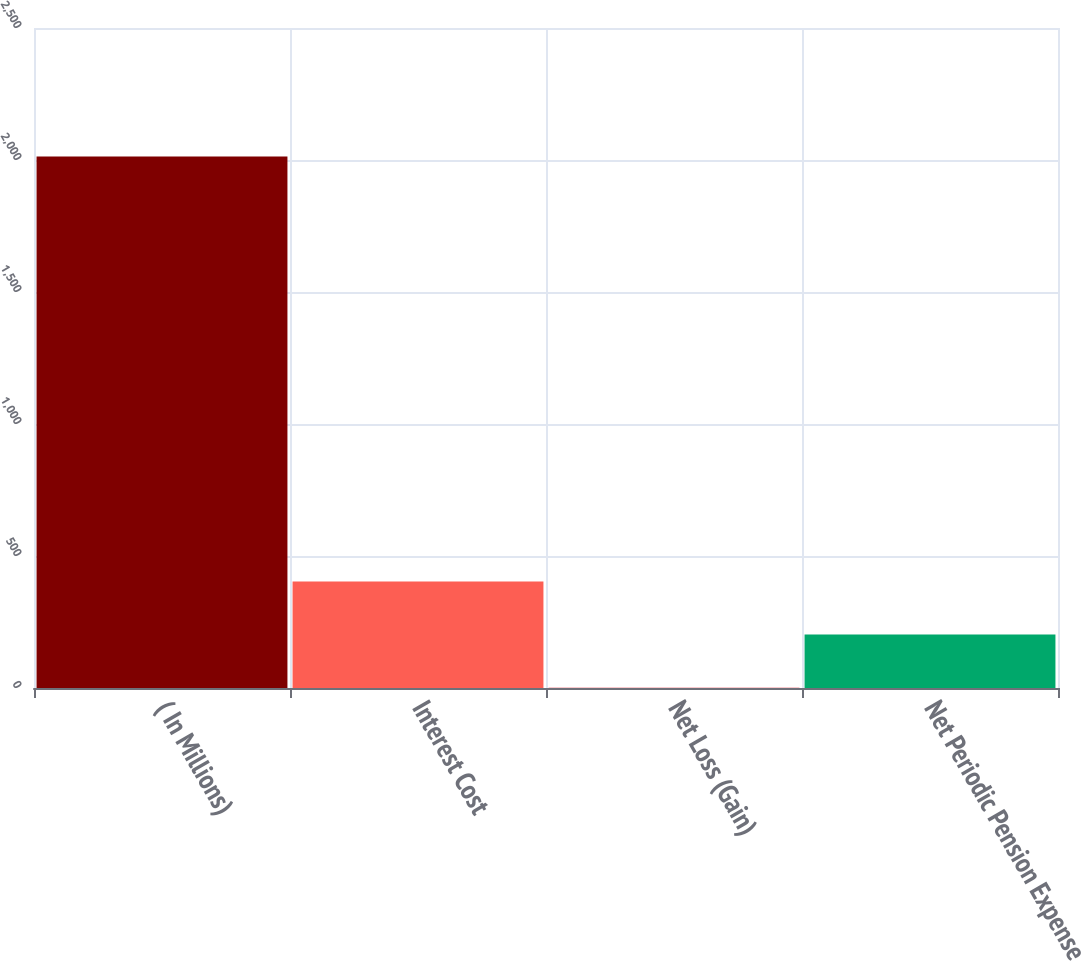Convert chart. <chart><loc_0><loc_0><loc_500><loc_500><bar_chart><fcel>( In Millions)<fcel>Interest Cost<fcel>Net Loss (Gain)<fcel>Net Periodic Pension Expense<nl><fcel>2013<fcel>403.4<fcel>1<fcel>202.2<nl></chart> 